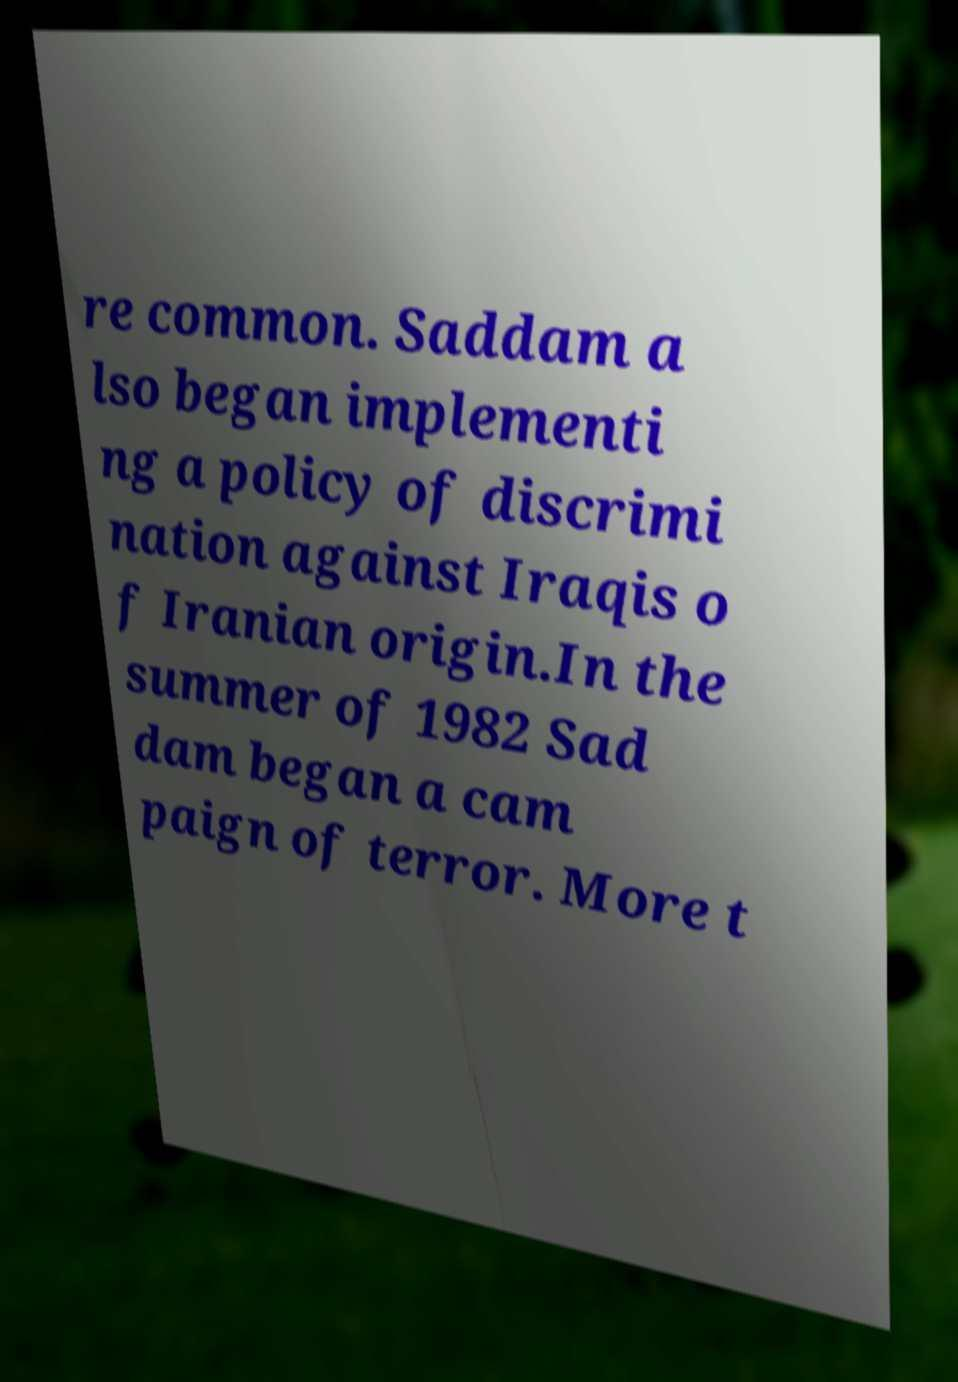Could you assist in decoding the text presented in this image and type it out clearly? re common. Saddam a lso began implementi ng a policy of discrimi nation against Iraqis o f Iranian origin.In the summer of 1982 Sad dam began a cam paign of terror. More t 